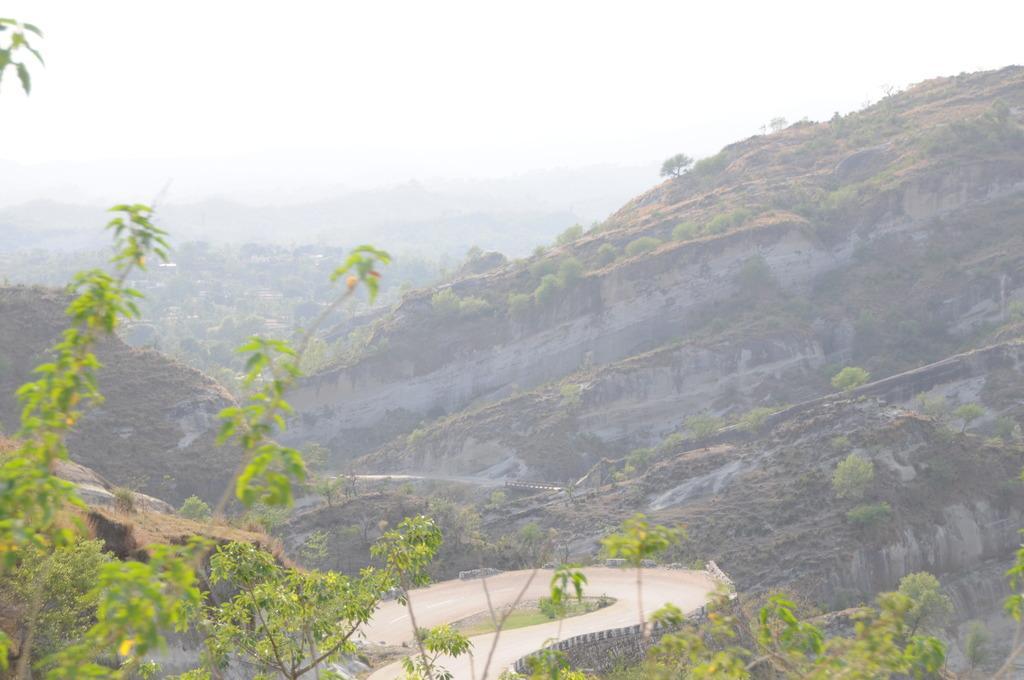Can you describe this image briefly? In this image I can see few plants and trees in green color. In the background I can see the mountains and the sky is in white color. 